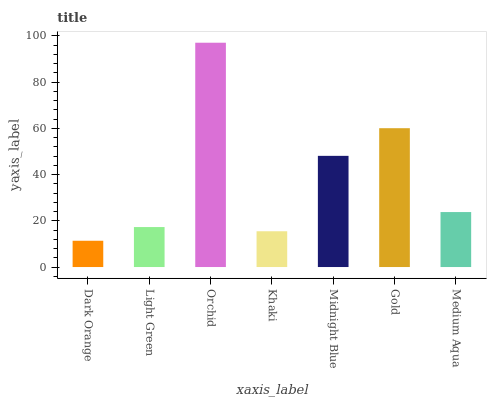Is Dark Orange the minimum?
Answer yes or no. Yes. Is Orchid the maximum?
Answer yes or no. Yes. Is Light Green the minimum?
Answer yes or no. No. Is Light Green the maximum?
Answer yes or no. No. Is Light Green greater than Dark Orange?
Answer yes or no. Yes. Is Dark Orange less than Light Green?
Answer yes or no. Yes. Is Dark Orange greater than Light Green?
Answer yes or no. No. Is Light Green less than Dark Orange?
Answer yes or no. No. Is Medium Aqua the high median?
Answer yes or no. Yes. Is Medium Aqua the low median?
Answer yes or no. Yes. Is Light Green the high median?
Answer yes or no. No. Is Light Green the low median?
Answer yes or no. No. 